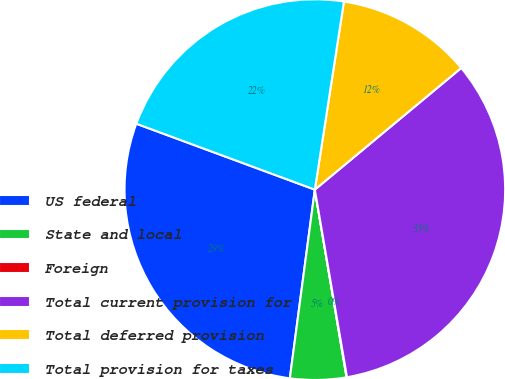<chart> <loc_0><loc_0><loc_500><loc_500><pie_chart><fcel>US federal<fcel>State and local<fcel>Foreign<fcel>Total current provision for<fcel>Total deferred provision<fcel>Total provision for taxes<nl><fcel>28.53%<fcel>4.76%<fcel>0.04%<fcel>33.33%<fcel>11.52%<fcel>21.81%<nl></chart> 